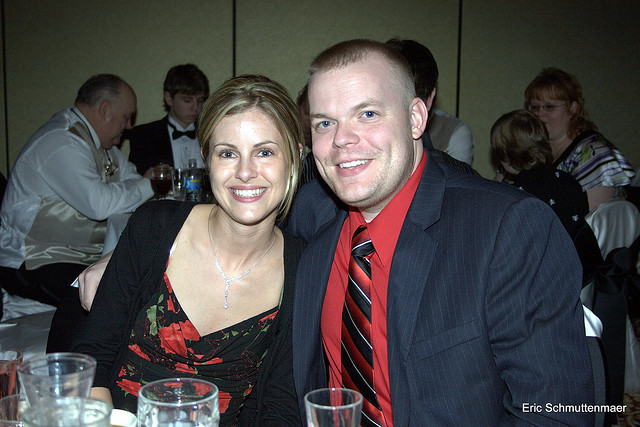<image>What type of glass is the woman holding? I don't know what type of glass the woman is holding. It could be a wine glass or a champagne flute.
 What type of glass is the woman holding? I don't know what type of glass is the woman holding. It can be seen as a wine glass, plastic or champagne flute. 